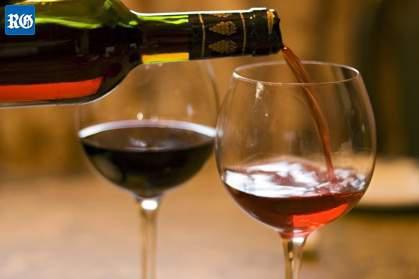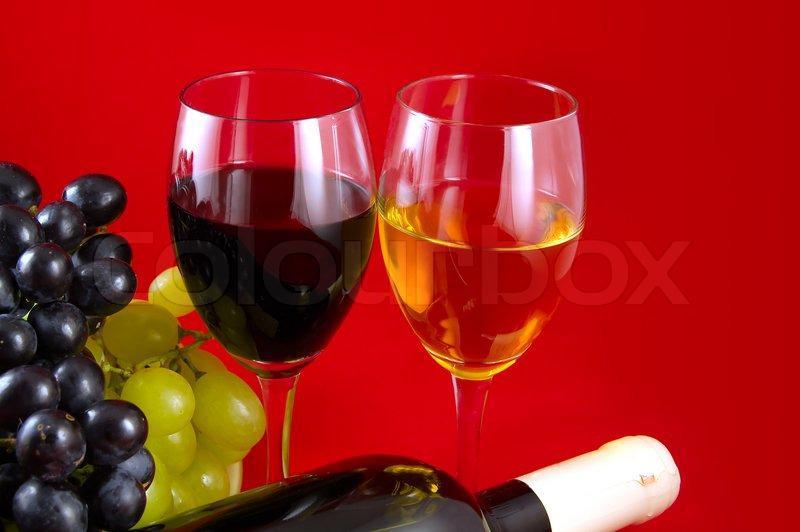The first image is the image on the left, the second image is the image on the right. For the images displayed, is the sentence "There is a red bottle of wine with a red top mostly full to the left of a single stemed glass of  red wine filled to the halfway point." factually correct? Answer yes or no. No. 